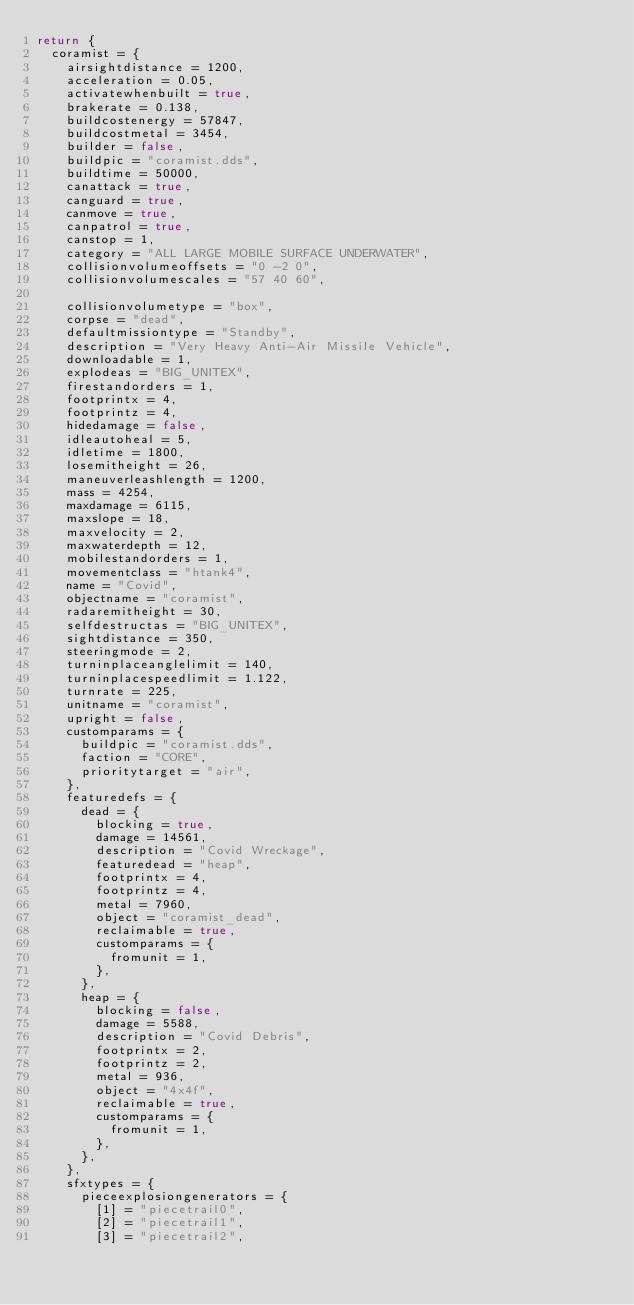<code> <loc_0><loc_0><loc_500><loc_500><_Lua_>return {
	coramist = {
		airsightdistance = 1200,
		acceleration = 0.05,
		activatewhenbuilt = true,
		brakerate = 0.138,
		buildcostenergy = 57847,
		buildcostmetal = 3454,
		builder = false,
		buildpic = "coramist.dds",
		buildtime = 50000,
		canattack = true,
		canguard = true,
		canmove = true,
		canpatrol = true,
		canstop = 1,
		category = "ALL LARGE MOBILE SURFACE UNDERWATER",
		collisionvolumeoffsets = "0 -2 0",
		collisionvolumescales = "57 40 60",
		
		collisionvolumetype = "box",
		corpse = "dead",
		defaultmissiontype = "Standby",
		description = "Very Heavy Anti-Air Missile Vehicle",
		downloadable = 1,
		explodeas = "BIG_UNITEX",
		firestandorders = 1,
		footprintx = 4,
		footprintz = 4,
		hidedamage = false,
		idleautoheal = 5,
		idletime = 1800,
		losemitheight = 26,
		maneuverleashlength = 1200,
		mass = 4254,
		maxdamage = 6115,
		maxslope = 18,
		maxvelocity = 2,
		maxwaterdepth = 12,
		mobilestandorders = 1,
		movementclass = "htank4",
		name = "Covid",
		objectname = "coramist",
		radaremitheight = 30,
		selfdestructas = "BIG_UNITEX",
		sightdistance = 350,
		steeringmode = 2,
		turninplaceanglelimit = 140,
		turninplacespeedlimit = 1.122,
		turnrate = 225,
		unitname = "coramist",
		upright = false,
		customparams = {
			buildpic = "coramist.dds",
			faction = "CORE",
			prioritytarget = "air",
		},
		featuredefs = {
			dead = {
				blocking = true,
				damage = 14561,
				description = "Covid Wreckage",
				featuredead = "heap",
				footprintx = 4,
				footprintz = 4,
				metal = 7960,
				object = "coramist_dead",
				reclaimable = true,
				customparams = {
					fromunit = 1,
				},
			},
			heap = {
				blocking = false,
				damage = 5588,
				description = "Covid Debris",
				footprintx = 2,
				footprintz = 2,
				metal = 936,
				object = "4x4f",
				reclaimable = true,
				customparams = {
					fromunit = 1,
				},
			},
		},
		sfxtypes = {
			pieceexplosiongenerators = {
				[1] = "piecetrail0",
				[2] = "piecetrail1",
				[3] = "piecetrail2",</code> 